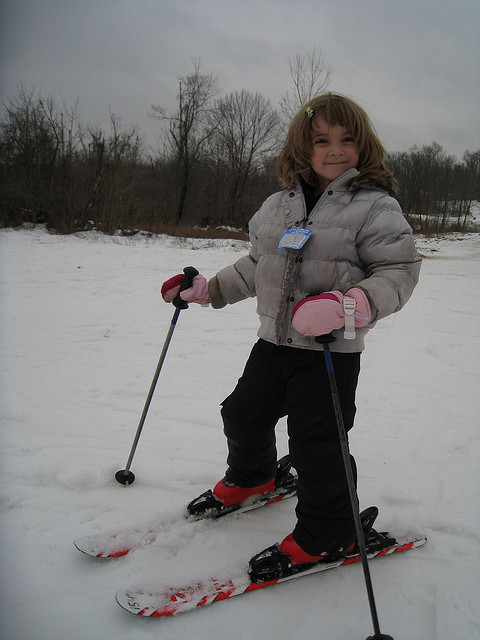Does the little girl like skiing? Based on her posture and the smile on her face, it seems the little girl enjoys skiing. She's standing confidently on her skis, suggesting a positive experience. 